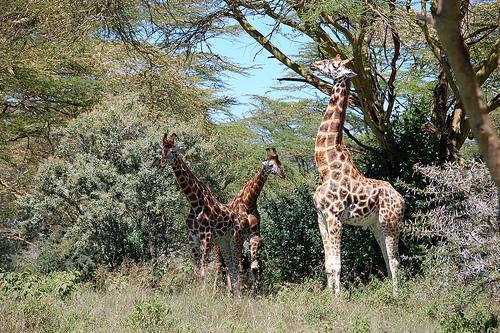How many animals are shown?
Give a very brief answer. 3. How many full grown animals are shown?
Give a very brief answer. 1. 